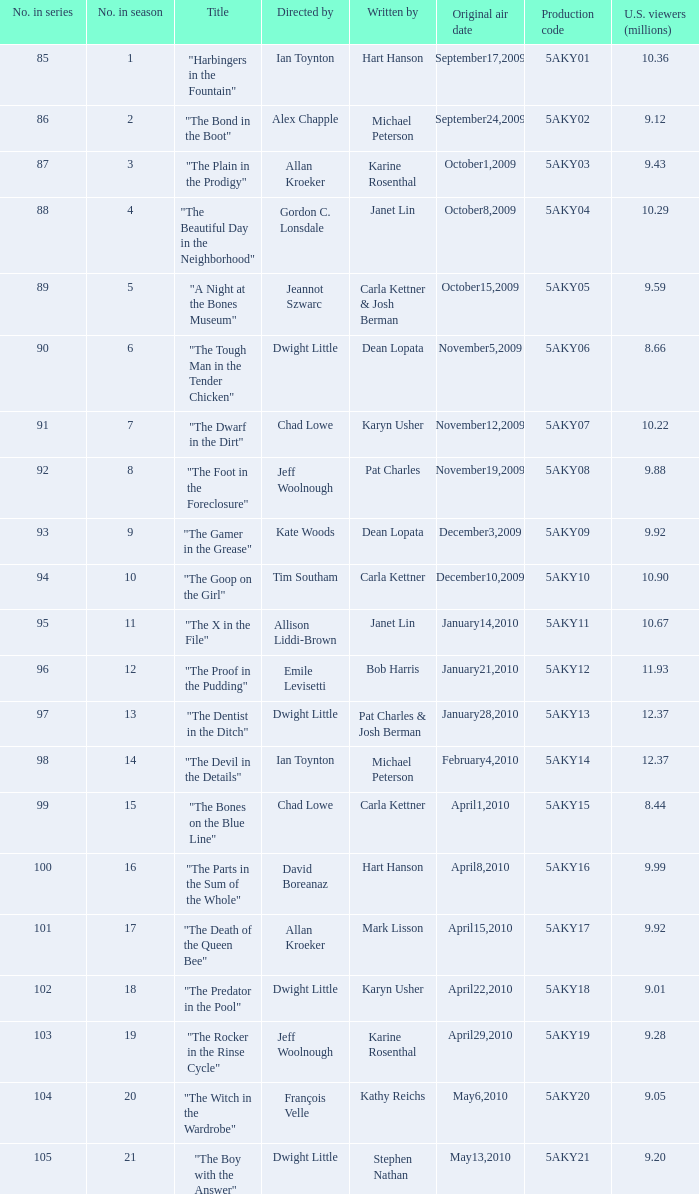How many us viewers (in millions) watched the episode authored by gordon c. lonsdale? 10.29. 